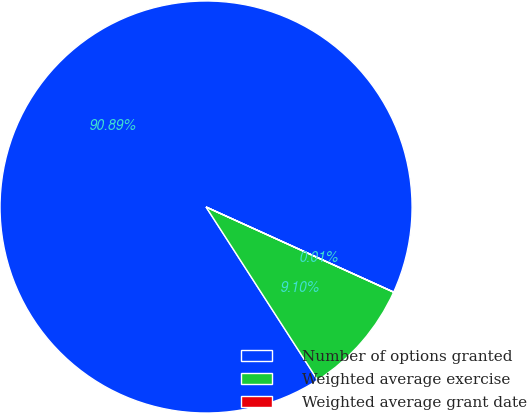Convert chart. <chart><loc_0><loc_0><loc_500><loc_500><pie_chart><fcel>Number of options granted<fcel>Weighted average exercise<fcel>Weighted average grant date<nl><fcel>90.9%<fcel>9.1%<fcel>0.01%<nl></chart> 